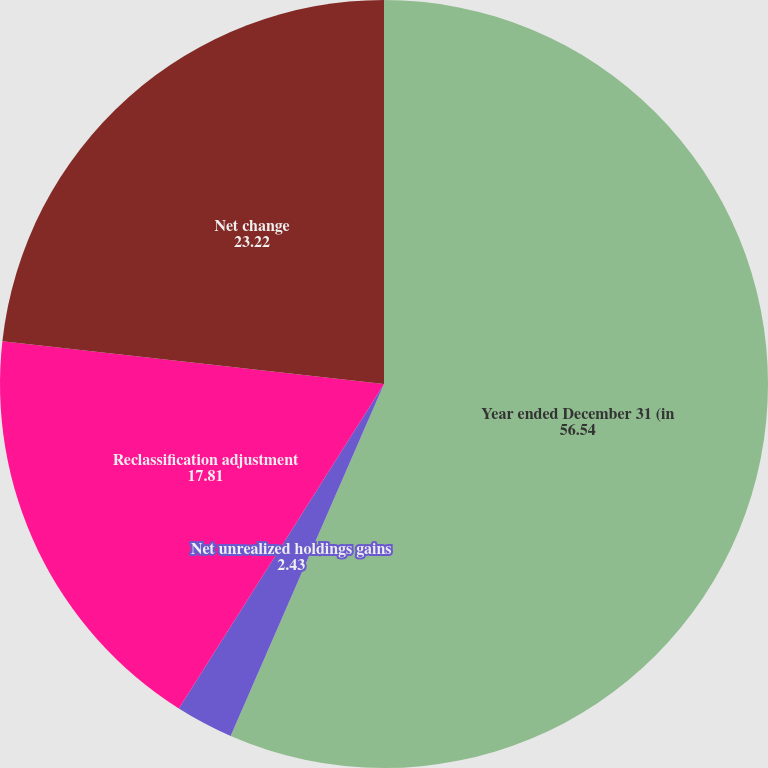Convert chart to OTSL. <chart><loc_0><loc_0><loc_500><loc_500><pie_chart><fcel>Year ended December 31 (in<fcel>Net unrealized holdings gains<fcel>Reclassification adjustment<fcel>Net change<nl><fcel>56.54%<fcel>2.43%<fcel>17.81%<fcel>23.22%<nl></chart> 